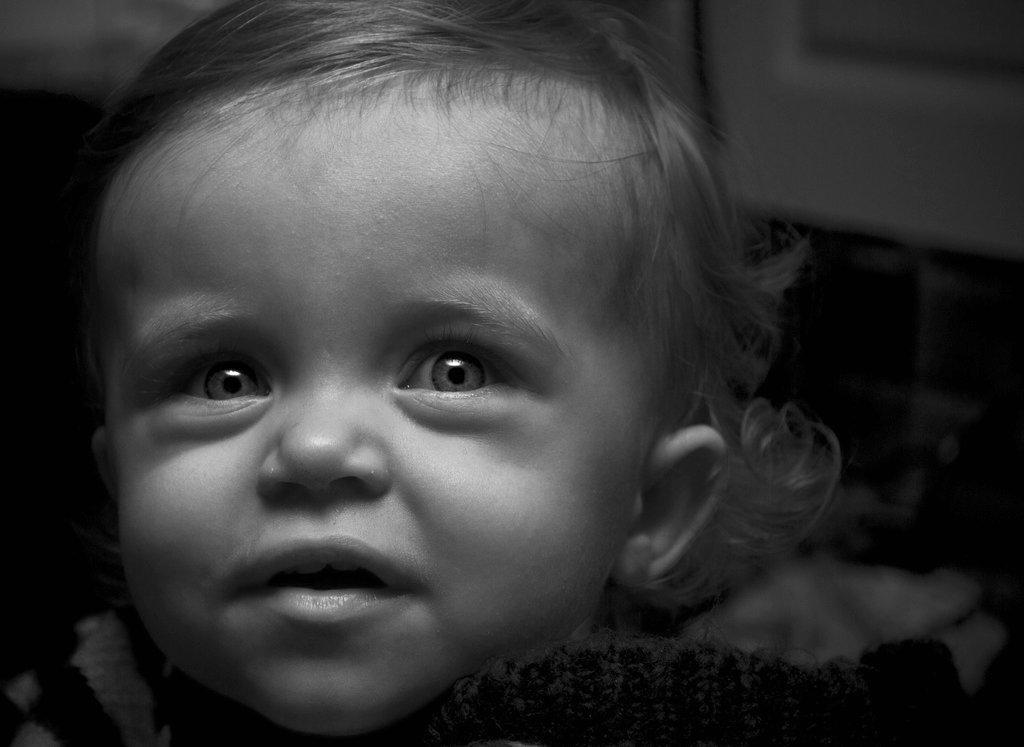Can you describe this image briefly? In this image we can see a kid and blurry background. 